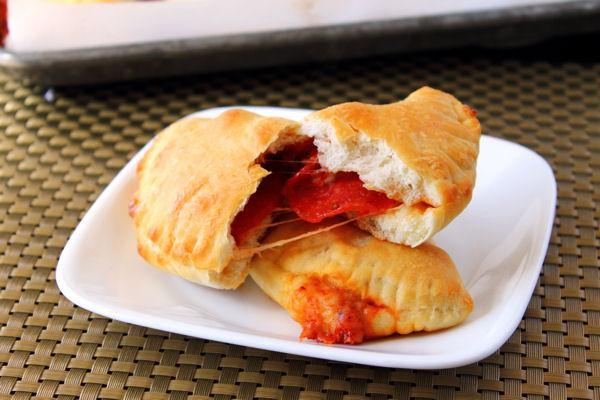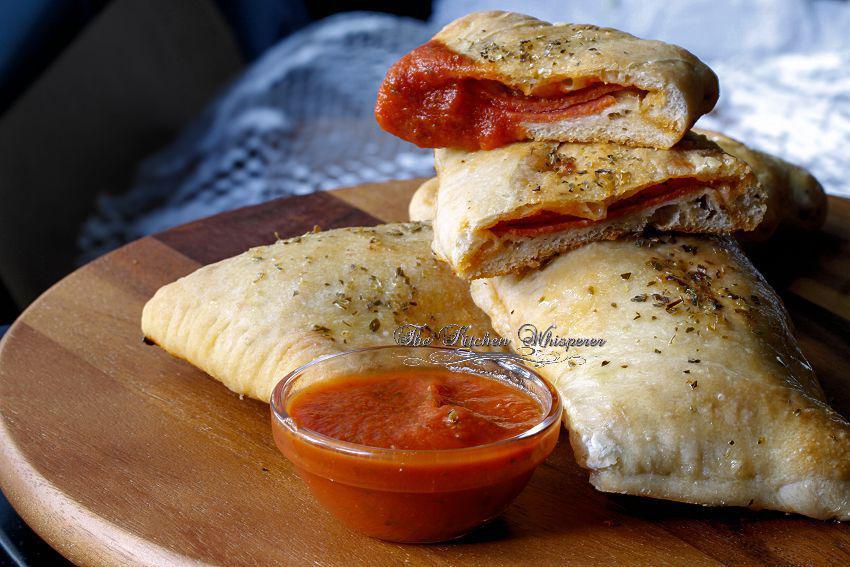The first image is the image on the left, the second image is the image on the right. Considering the images on both sides, is "The left image shows calzones on a non-white plate." valid? Answer yes or no. No. The first image is the image on the left, the second image is the image on the right. Considering the images on both sides, is "In the left image the food is on a white plate." valid? Answer yes or no. Yes. 